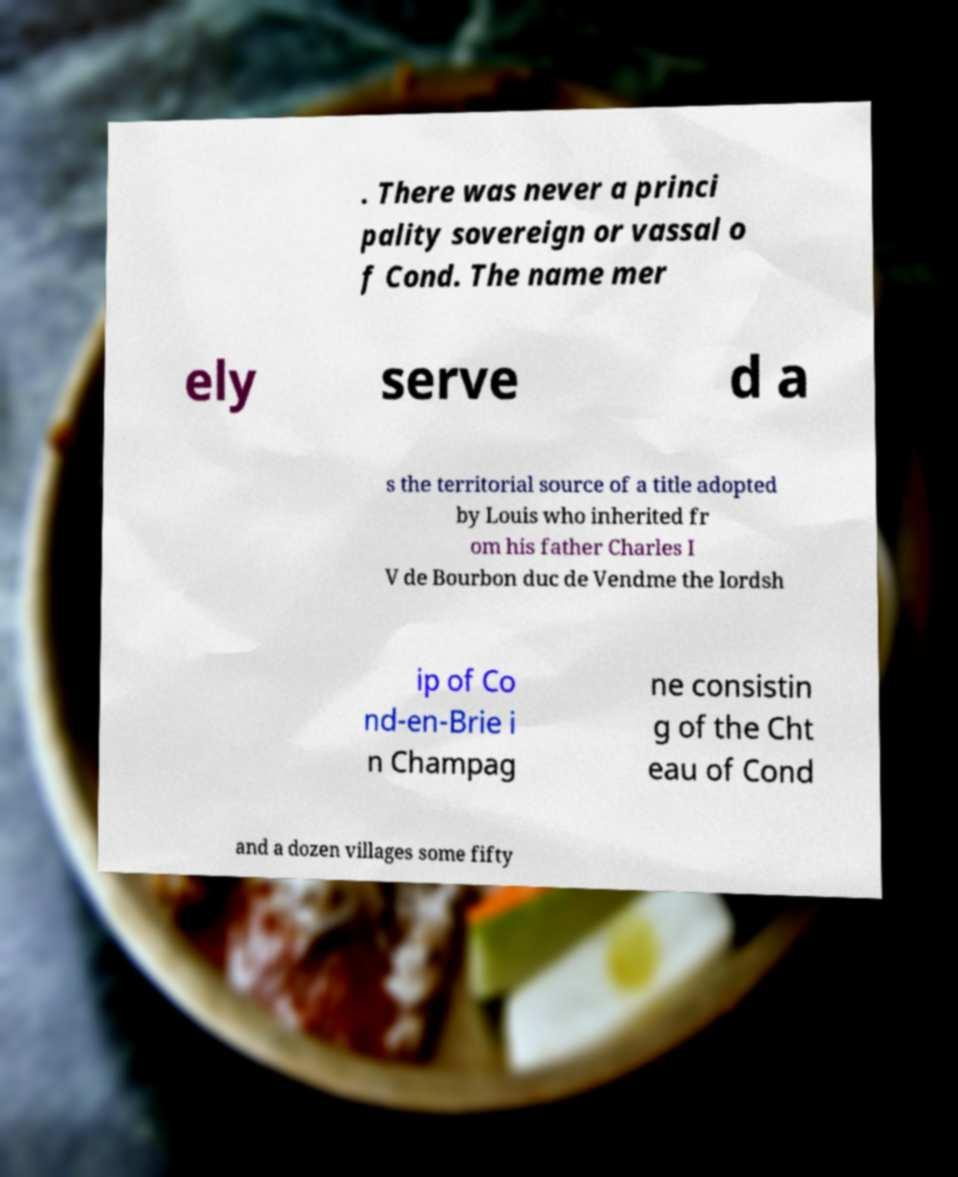There's text embedded in this image that I need extracted. Can you transcribe it verbatim? . There was never a princi pality sovereign or vassal o f Cond. The name mer ely serve d a s the territorial source of a title adopted by Louis who inherited fr om his father Charles I V de Bourbon duc de Vendme the lordsh ip of Co nd-en-Brie i n Champag ne consistin g of the Cht eau of Cond and a dozen villages some fifty 